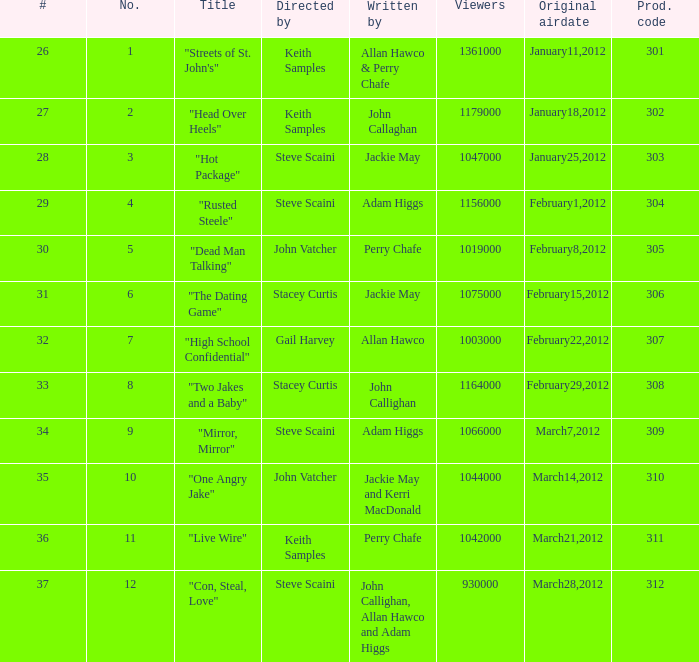What is the total number of films directy and written by john callaghan? 1.0. Parse the table in full. {'header': ['#', 'No.', 'Title', 'Directed by', 'Written by', 'Viewers', 'Original airdate', 'Prod. code'], 'rows': [['26', '1', '"Streets of St. John\'s"', 'Keith Samples', 'Allan Hawco & Perry Chafe', '1361000', 'January11,2012', '301'], ['27', '2', '"Head Over Heels"', 'Keith Samples', 'John Callaghan', '1179000', 'January18,2012', '302'], ['28', '3', '"Hot Package"', 'Steve Scaini', 'Jackie May', '1047000', 'January25,2012', '303'], ['29', '4', '"Rusted Steele"', 'Steve Scaini', 'Adam Higgs', '1156000', 'February1,2012', '304'], ['30', '5', '"Dead Man Talking"', 'John Vatcher', 'Perry Chafe', '1019000', 'February8,2012', '305'], ['31', '6', '"The Dating Game"', 'Stacey Curtis', 'Jackie May', '1075000', 'February15,2012', '306'], ['32', '7', '"High School Confidential"', 'Gail Harvey', 'Allan Hawco', '1003000', 'February22,2012', '307'], ['33', '8', '"Two Jakes and a Baby"', 'Stacey Curtis', 'John Callighan', '1164000', 'February29,2012', '308'], ['34', '9', '"Mirror, Mirror"', 'Steve Scaini', 'Adam Higgs', '1066000', 'March7,2012', '309'], ['35', '10', '"One Angry Jake"', 'John Vatcher', 'Jackie May and Kerri MacDonald', '1044000', 'March14,2012', '310'], ['36', '11', '"Live Wire"', 'Keith Samples', 'Perry Chafe', '1042000', 'March21,2012', '311'], ['37', '12', '"Con, Steal, Love"', 'Steve Scaini', 'John Callighan, Allan Hawco and Adam Higgs', '930000', 'March28,2012', '312']]} 